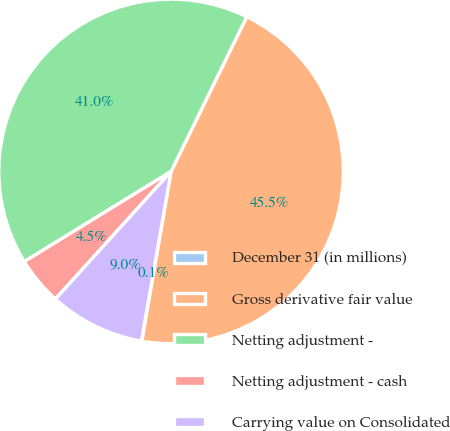Convert chart. <chart><loc_0><loc_0><loc_500><loc_500><pie_chart><fcel>December 31 (in millions)<fcel>Gross derivative fair value<fcel>Netting adjustment -<fcel>Netting adjustment - cash<fcel>Carrying value on Consolidated<nl><fcel>0.05%<fcel>45.47%<fcel>41.01%<fcel>4.51%<fcel>8.96%<nl></chart> 